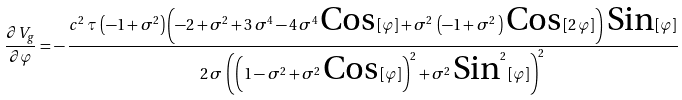Convert formula to latex. <formula><loc_0><loc_0><loc_500><loc_500>\frac { { \partial } V _ { g } } { \partial { \varphi } } = - \, \frac { c ^ { 2 } \, \tau \, \left ( - 1 + \sigma ^ { 2 } \right ) \left ( - 2 + \sigma ^ { 2 } + 3 \, \sigma ^ { 4 } - 4 \, \sigma ^ { 4 } \, \text {Cos} \, [ \varphi ] + \sigma ^ { 2 } \, \left ( - 1 + \sigma ^ { 2 } \, \right ) \, \text {Cos} \, [ 2 \, \varphi ] \right ) \, \text {Sin} \, [ \varphi ] } { 2 \, \sigma \, \left ( \left ( 1 - \sigma ^ { 2 } + \sigma ^ { 2 } \, \text {Cos} \, [ \varphi ] \right ) ^ { 2 } + \sigma ^ { 2 } \, \text {Sin} ^ { 2 } \, [ \varphi ] \right ) ^ { 2 } }</formula> 